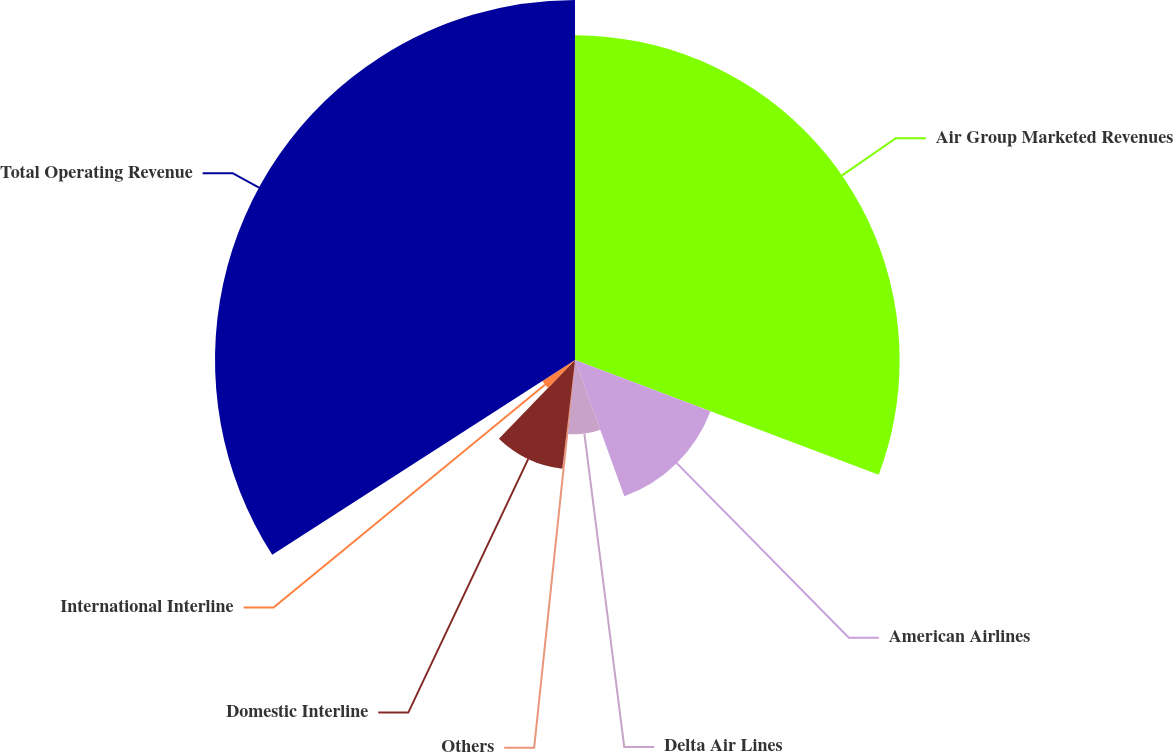Convert chart. <chart><loc_0><loc_0><loc_500><loc_500><pie_chart><fcel>Air Group Marketed Revenues<fcel>American Airlines<fcel>Delta Air Lines<fcel>Others<fcel>Domestic Interline<fcel>International Interline<fcel>Total Operating Revenue<nl><fcel>30.75%<fcel>13.72%<fcel>7.03%<fcel>0.34%<fcel>10.38%<fcel>3.68%<fcel>34.1%<nl></chart> 